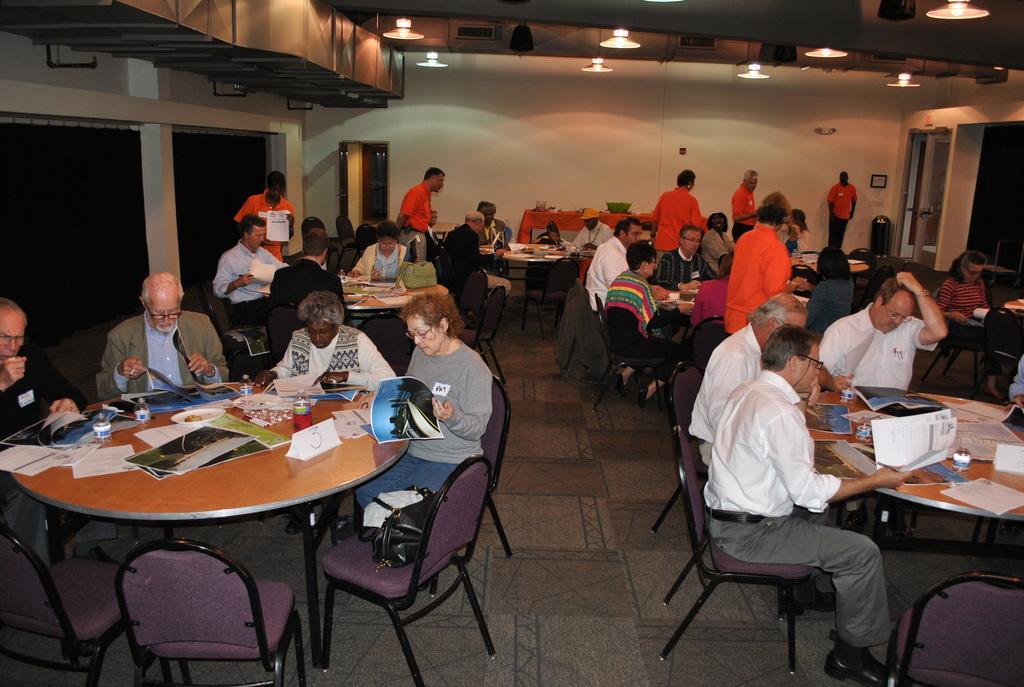Can you describe this image briefly? In this image In the middle there is a table on that there are many papers, books, bottle, plate. Around the table four people are sitting on the chairs. On the right there is a man he wears white shirt, trouser, belt and shoes. In the back ground there are many people, tables, chairs and there is wall, door and light. 